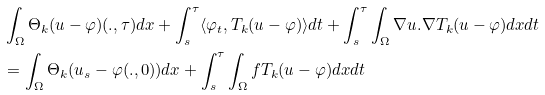Convert formula to latex. <formula><loc_0><loc_0><loc_500><loc_500>& \int _ { \Omega } \Theta _ { k } ( u - \varphi ) ( . , \tau ) d x + \int _ { s } ^ { \tau } \langle \varphi _ { t } , T _ { k } ( u - \varphi ) \rangle d t + \int _ { s } ^ { \tau } \int _ { \Omega } \nabla u . \nabla T _ { k } ( u - \varphi ) d x d t \\ & = \int _ { \Omega } \Theta _ { k } ( u _ { s } - \varphi ( . , 0 ) ) d x + \int _ { s } ^ { \tau } \int _ { \Omega } f T _ { k } ( u - \varphi ) d x d t</formula> 